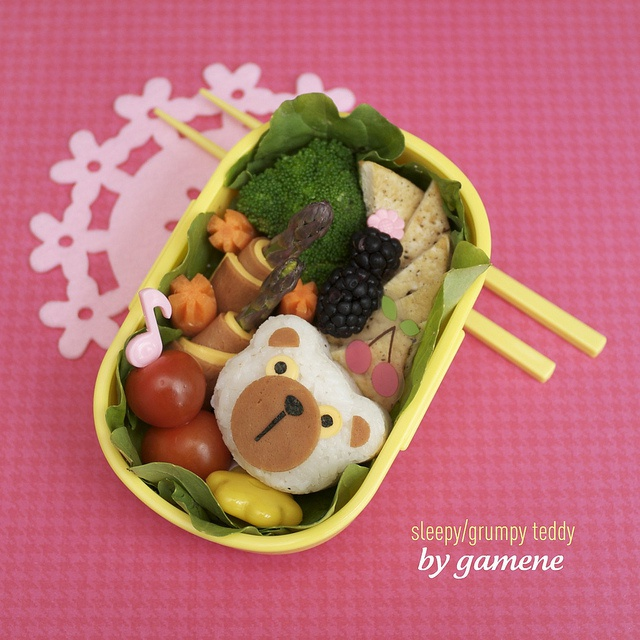Describe the objects in this image and their specific colors. I can see teddy bear in salmon, gray, lightgray, tan, and brown tones, broccoli in salmon, darkgreen, and maroon tones, carrot in salmon, brown, red, and orange tones, carrot in salmon, brown, orange, and maroon tones, and carrot in salmon, brown, red, and maroon tones in this image. 